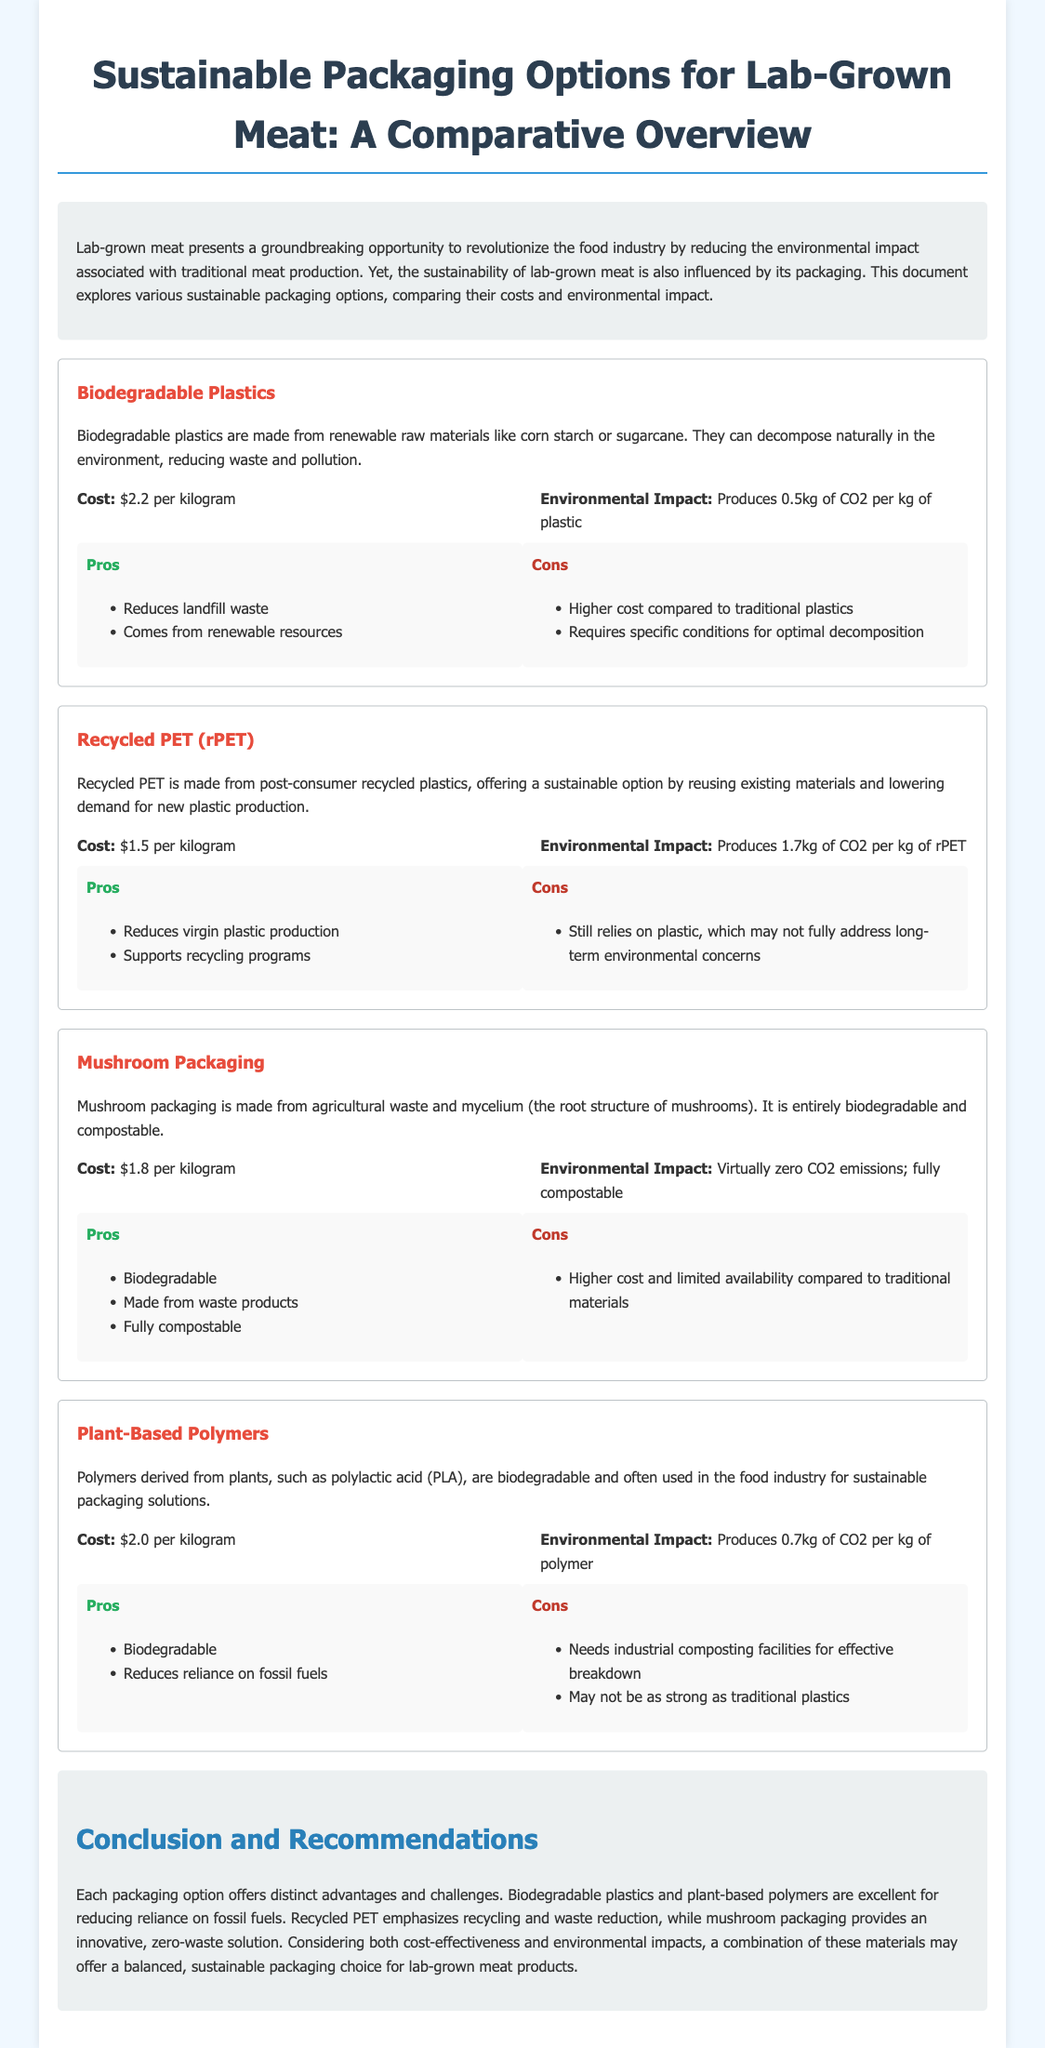What is the cost of Biodegradable Plastics? The cost of Biodegradable Plastics is mentioned as $2.2 per kilogram.
Answer: $2.2 per kilogram What is the environmental impact of Recycled PET? The document states that Recycled PET produces 1.7kg of CO2 per kg of rPET.
Answer: 1.7kg of CO2 per kg of rPET What material is used in Mushroom Packaging? Mushroom Packaging is made from agricultural waste and mycelium.
Answer: Agricultural waste and mycelium What is a key benefit of Plant-Based Polymers? A key benefit of Plant-Based Polymers mentioned is that they are biodegradable.
Answer: Biodegradable Which packaging option has virtually zero CO2 emissions? The document highlights that Mushroom Packaging has virtually zero CO2 emissions.
Answer: Mushroom Packaging How does the cost of Recycled PET compare with Biodegradable Plastics? Recycled PET is cheaper than Biodegradable Plastics, as it costs $1.5 per kg compared to $2.2 per kg for Biodegradable Plastics.
Answer: Cheaper What are two materials that reduce reliance on fossil fuels? The document states that Biodegradable Plastics and Plant-Based Polymers reduce reliance on fossil fuels.
Answer: Biodegradable Plastics and Plant-Based Polymers What is a disadvantage of using Plant-Based Polymers? The disadvantage mentioned for Plant-Based Polymers is that they need industrial composting facilities for effective breakdown.
Answer: Need industrial composting facilities What is the main focus of the document? The document primarily focuses on comparing sustainable packaging options for lab-grown meat.
Answer: Comparing sustainable packaging options for lab-grown meat 